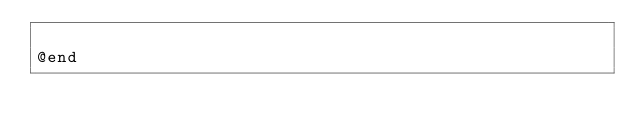<code> <loc_0><loc_0><loc_500><loc_500><_C_>
@end
</code> 